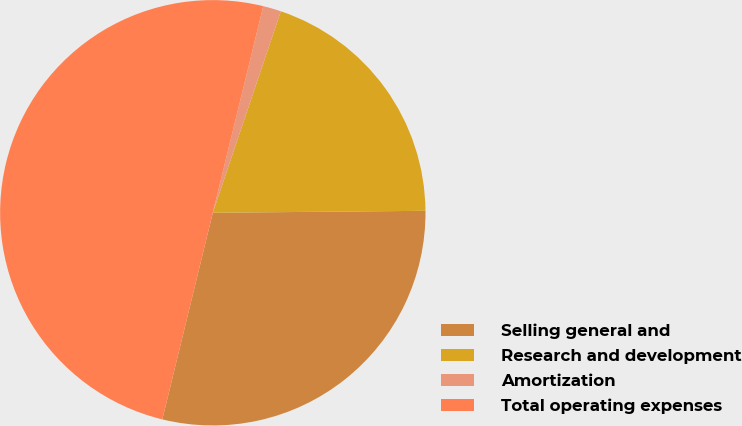Convert chart to OTSL. <chart><loc_0><loc_0><loc_500><loc_500><pie_chart><fcel>Selling general and<fcel>Research and development<fcel>Amortization<fcel>Total operating expenses<nl><fcel>28.96%<fcel>19.67%<fcel>1.37%<fcel>50.0%<nl></chart> 